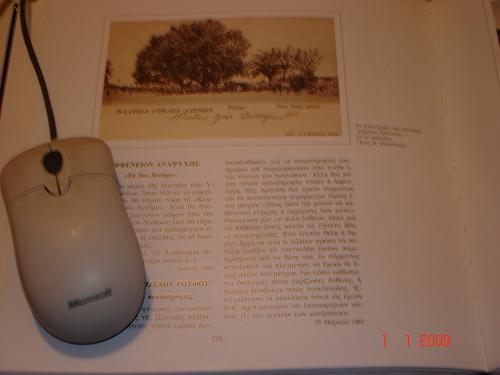How many mice are shown?
Give a very brief answer. 1. How many computer mouses are there?
Give a very brief answer. 1. 